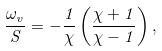<formula> <loc_0><loc_0><loc_500><loc_500>\frac { \omega _ { v } } { S } = - \frac { 1 } { \chi } \left ( \frac { \chi + 1 } { \chi - 1 } \right ) ,</formula> 